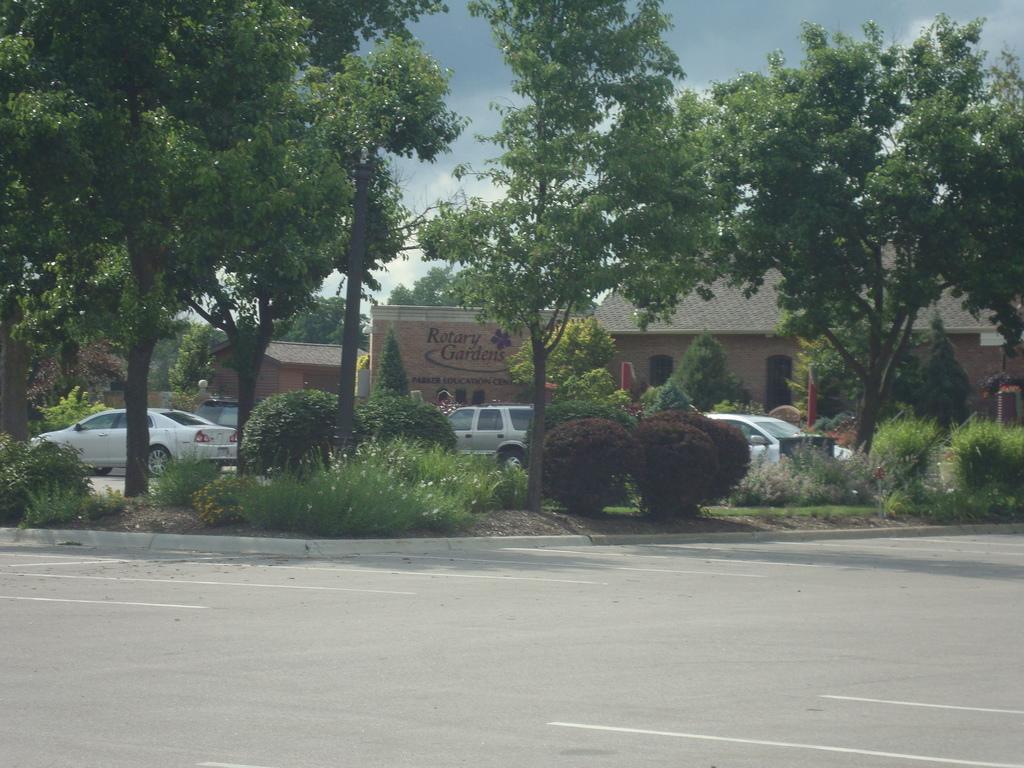Could you give a brief overview of what you see in this image? This picture is taken on the wide road. In this image, we can see some plants and trees. In the background, we can see few cars which are placed on the road, building and a person, trees, plants. At the top, we can see a sky which is a bit cloudy, at the bottom, we can see a road. 